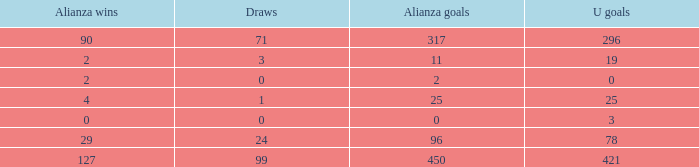Would you mind parsing the complete table? {'header': ['Alianza wins', 'Draws', 'Alianza goals', 'U goals'], 'rows': [['90', '71', '317', '296'], ['2', '3', '11', '19'], ['2', '0', '2', '0'], ['4', '1', '25', '25'], ['0', '0', '0', '3'], ['29', '24', '96', '78'], ['127', '99', '450', '421']]} What is the lowest Draws, when Alianza Goals is less than 317, when U Goals is less than 3, and when Alianza Wins is less than 2? None. 